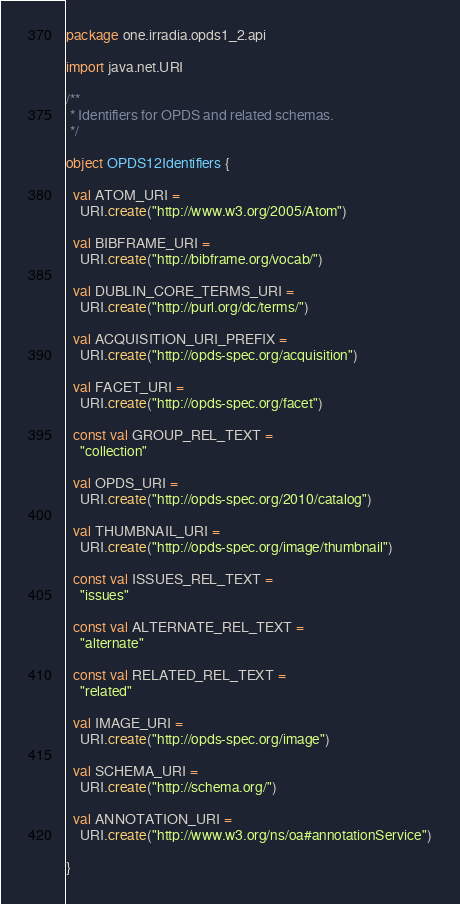Convert code to text. <code><loc_0><loc_0><loc_500><loc_500><_Kotlin_>package one.irradia.opds1_2.api

import java.net.URI

/**
 * Identifiers for OPDS and related schemas.
 */

object OPDS12Identifiers {

  val ATOM_URI =
    URI.create("http://www.w3.org/2005/Atom")

  val BIBFRAME_URI =
    URI.create("http://bibframe.org/vocab/")

  val DUBLIN_CORE_TERMS_URI =
    URI.create("http://purl.org/dc/terms/")

  val ACQUISITION_URI_PREFIX =
    URI.create("http://opds-spec.org/acquisition")

  val FACET_URI =
    URI.create("http://opds-spec.org/facet")

  const val GROUP_REL_TEXT =
    "collection"

  val OPDS_URI =
    URI.create("http://opds-spec.org/2010/catalog")

  val THUMBNAIL_URI =
    URI.create("http://opds-spec.org/image/thumbnail")

  const val ISSUES_REL_TEXT =
    "issues"

  const val ALTERNATE_REL_TEXT =
    "alternate"

  const val RELATED_REL_TEXT =
    "related"

  val IMAGE_URI =
    URI.create("http://opds-spec.org/image")

  val SCHEMA_URI =
    URI.create("http://schema.org/")

  val ANNOTATION_URI =
    URI.create("http://www.w3.org/ns/oa#annotationService")

}
</code> 